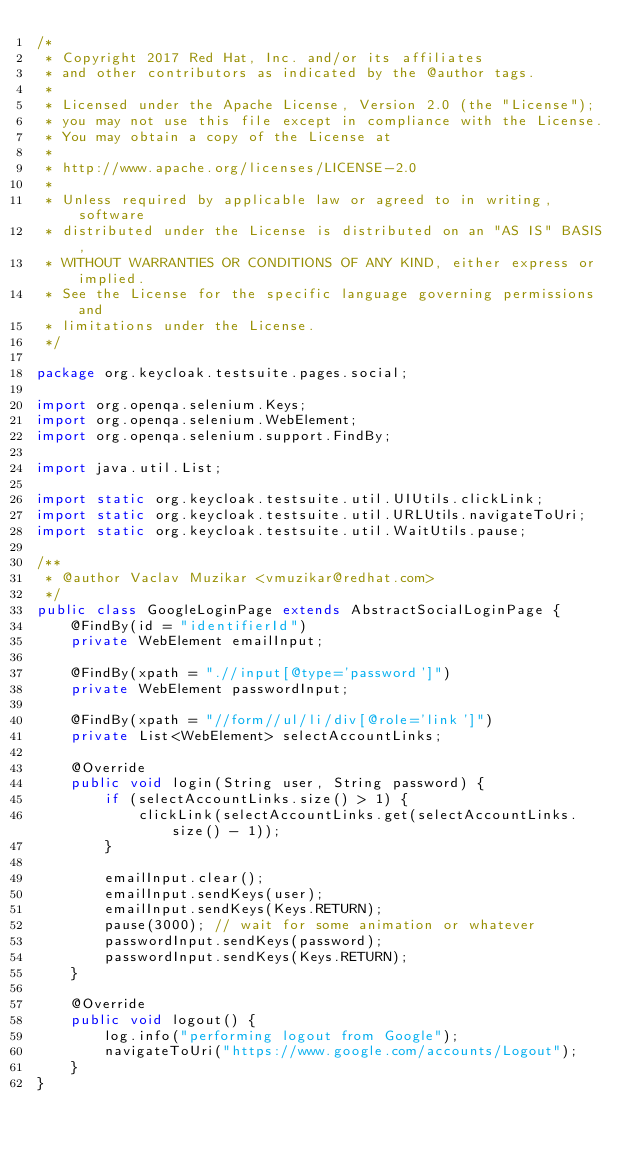Convert code to text. <code><loc_0><loc_0><loc_500><loc_500><_Java_>/*
 * Copyright 2017 Red Hat, Inc. and/or its affiliates
 * and other contributors as indicated by the @author tags.
 *
 * Licensed under the Apache License, Version 2.0 (the "License");
 * you may not use this file except in compliance with the License.
 * You may obtain a copy of the License at
 *
 * http://www.apache.org/licenses/LICENSE-2.0
 *
 * Unless required by applicable law or agreed to in writing, software
 * distributed under the License is distributed on an "AS IS" BASIS,
 * WITHOUT WARRANTIES OR CONDITIONS OF ANY KIND, either express or implied.
 * See the License for the specific language governing permissions and
 * limitations under the License.
 */

package org.keycloak.testsuite.pages.social;

import org.openqa.selenium.Keys;
import org.openqa.selenium.WebElement;
import org.openqa.selenium.support.FindBy;

import java.util.List;

import static org.keycloak.testsuite.util.UIUtils.clickLink;
import static org.keycloak.testsuite.util.URLUtils.navigateToUri;
import static org.keycloak.testsuite.util.WaitUtils.pause;

/**
 * @author Vaclav Muzikar <vmuzikar@redhat.com>
 */
public class GoogleLoginPage extends AbstractSocialLoginPage {
    @FindBy(id = "identifierId")
    private WebElement emailInput;

    @FindBy(xpath = ".//input[@type='password']")
    private WebElement passwordInput;

    @FindBy(xpath = "//form//ul/li/div[@role='link']")
    private List<WebElement> selectAccountLinks;

    @Override
    public void login(String user, String password) {
        if (selectAccountLinks.size() > 1) {
            clickLink(selectAccountLinks.get(selectAccountLinks.size() - 1));
        }

        emailInput.clear();
        emailInput.sendKeys(user);
        emailInput.sendKeys(Keys.RETURN);
        pause(3000); // wait for some animation or whatever
        passwordInput.sendKeys(password);
        passwordInput.sendKeys(Keys.RETURN);
    }

    @Override
    public void logout() {
        log.info("performing logout from Google");
        navigateToUri("https://www.google.com/accounts/Logout");
    }
}
</code> 